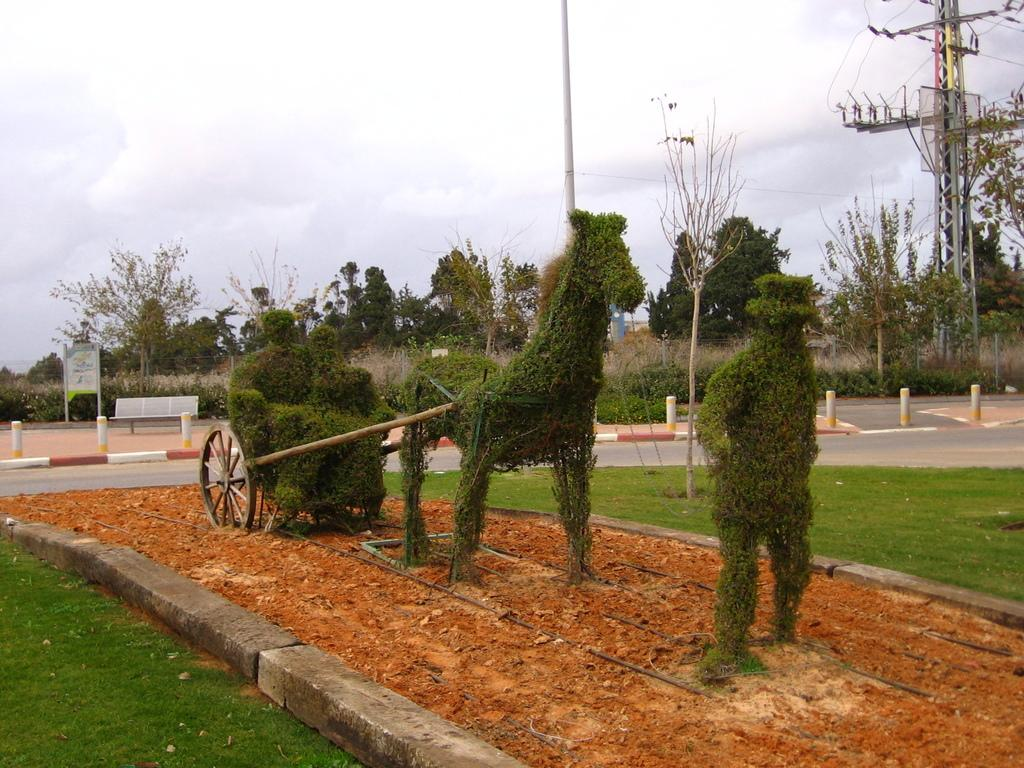What is located in the center of the image? There are plants in the center of the image. What can be seen in the background of the image? There is a road, trees, poles, and the sky visible in the background. What is the condition of the sky in the image? Clouds are present in the sky in the image. What organization is responsible for the trip depicted in the image? There is no trip depicted in the image, so it is not possible to determine which organization might be responsible. 